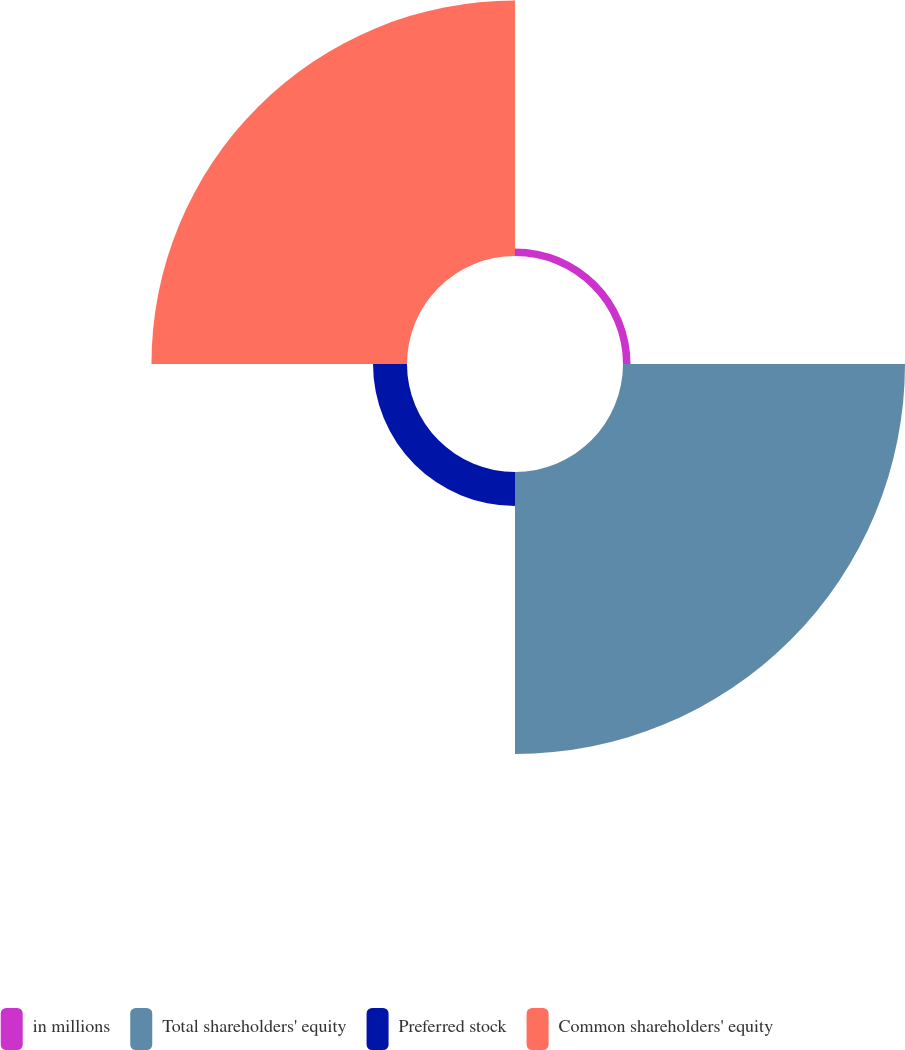Convert chart to OTSL. <chart><loc_0><loc_0><loc_500><loc_500><pie_chart><fcel>in millions<fcel>Total shareholders' equity<fcel>Preferred stock<fcel>Common shareholders' equity<nl><fcel>1.3%<fcel>48.7%<fcel>5.87%<fcel>44.13%<nl></chart> 